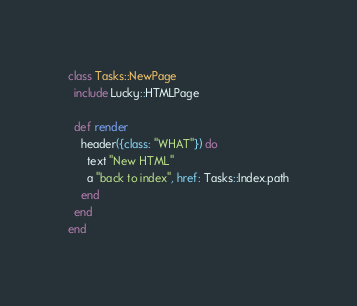<code> <loc_0><loc_0><loc_500><loc_500><_Crystal_>class Tasks::NewPage
  include Lucky::HTMLPage

  def render
    header({class: "WHAT"}) do
      text "New HTML"
      a "back to index", href: Tasks::Index.path
    end
  end
end
</code> 